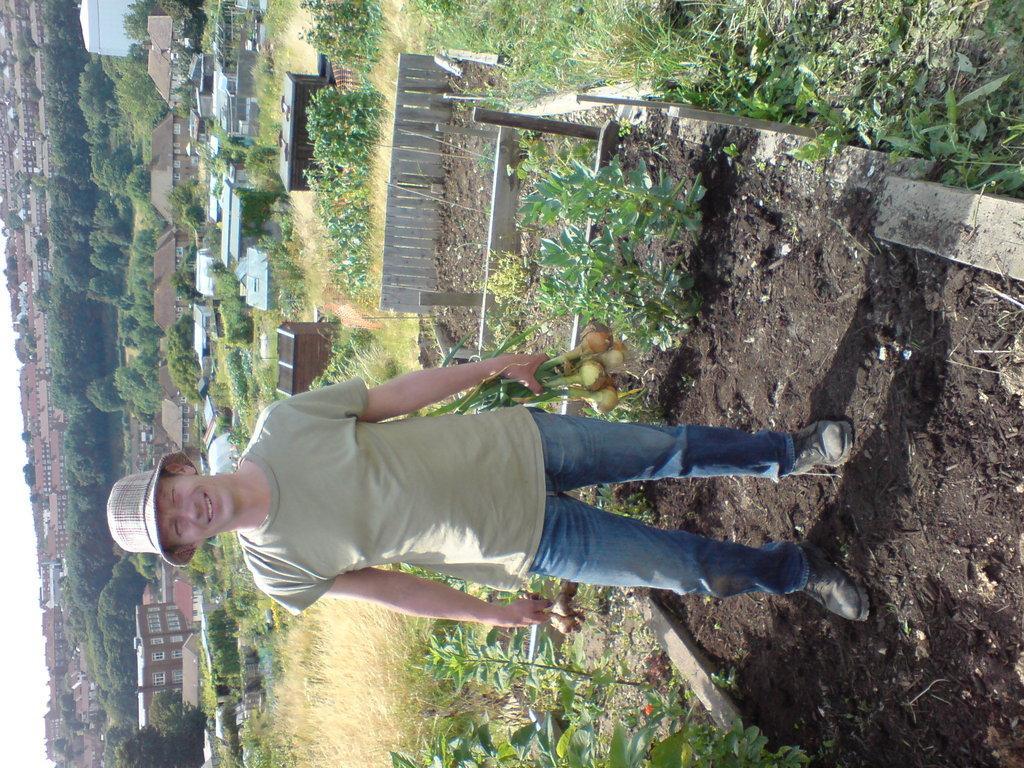Can you describe this image briefly? In this image there is a person standing and smiling holding vegetables, and in the background there are plants, houses, trees, sky. 